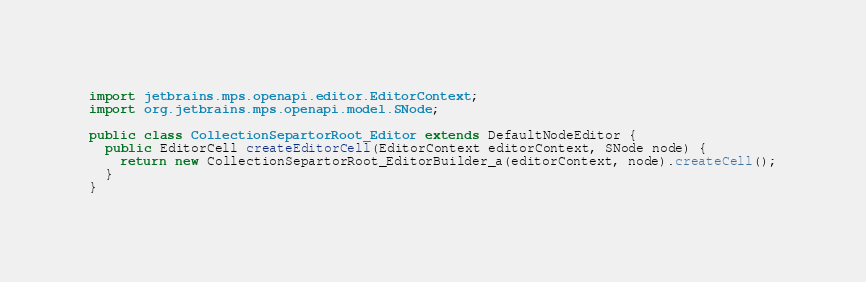<code> <loc_0><loc_0><loc_500><loc_500><_Java_>import jetbrains.mps.openapi.editor.EditorContext;
import org.jetbrains.mps.openapi.model.SNode;

public class CollectionSepartorRoot_Editor extends DefaultNodeEditor {
  public EditorCell createEditorCell(EditorContext editorContext, SNode node) {
    return new CollectionSepartorRoot_EditorBuilder_a(editorContext, node).createCell();
  }
}
</code> 